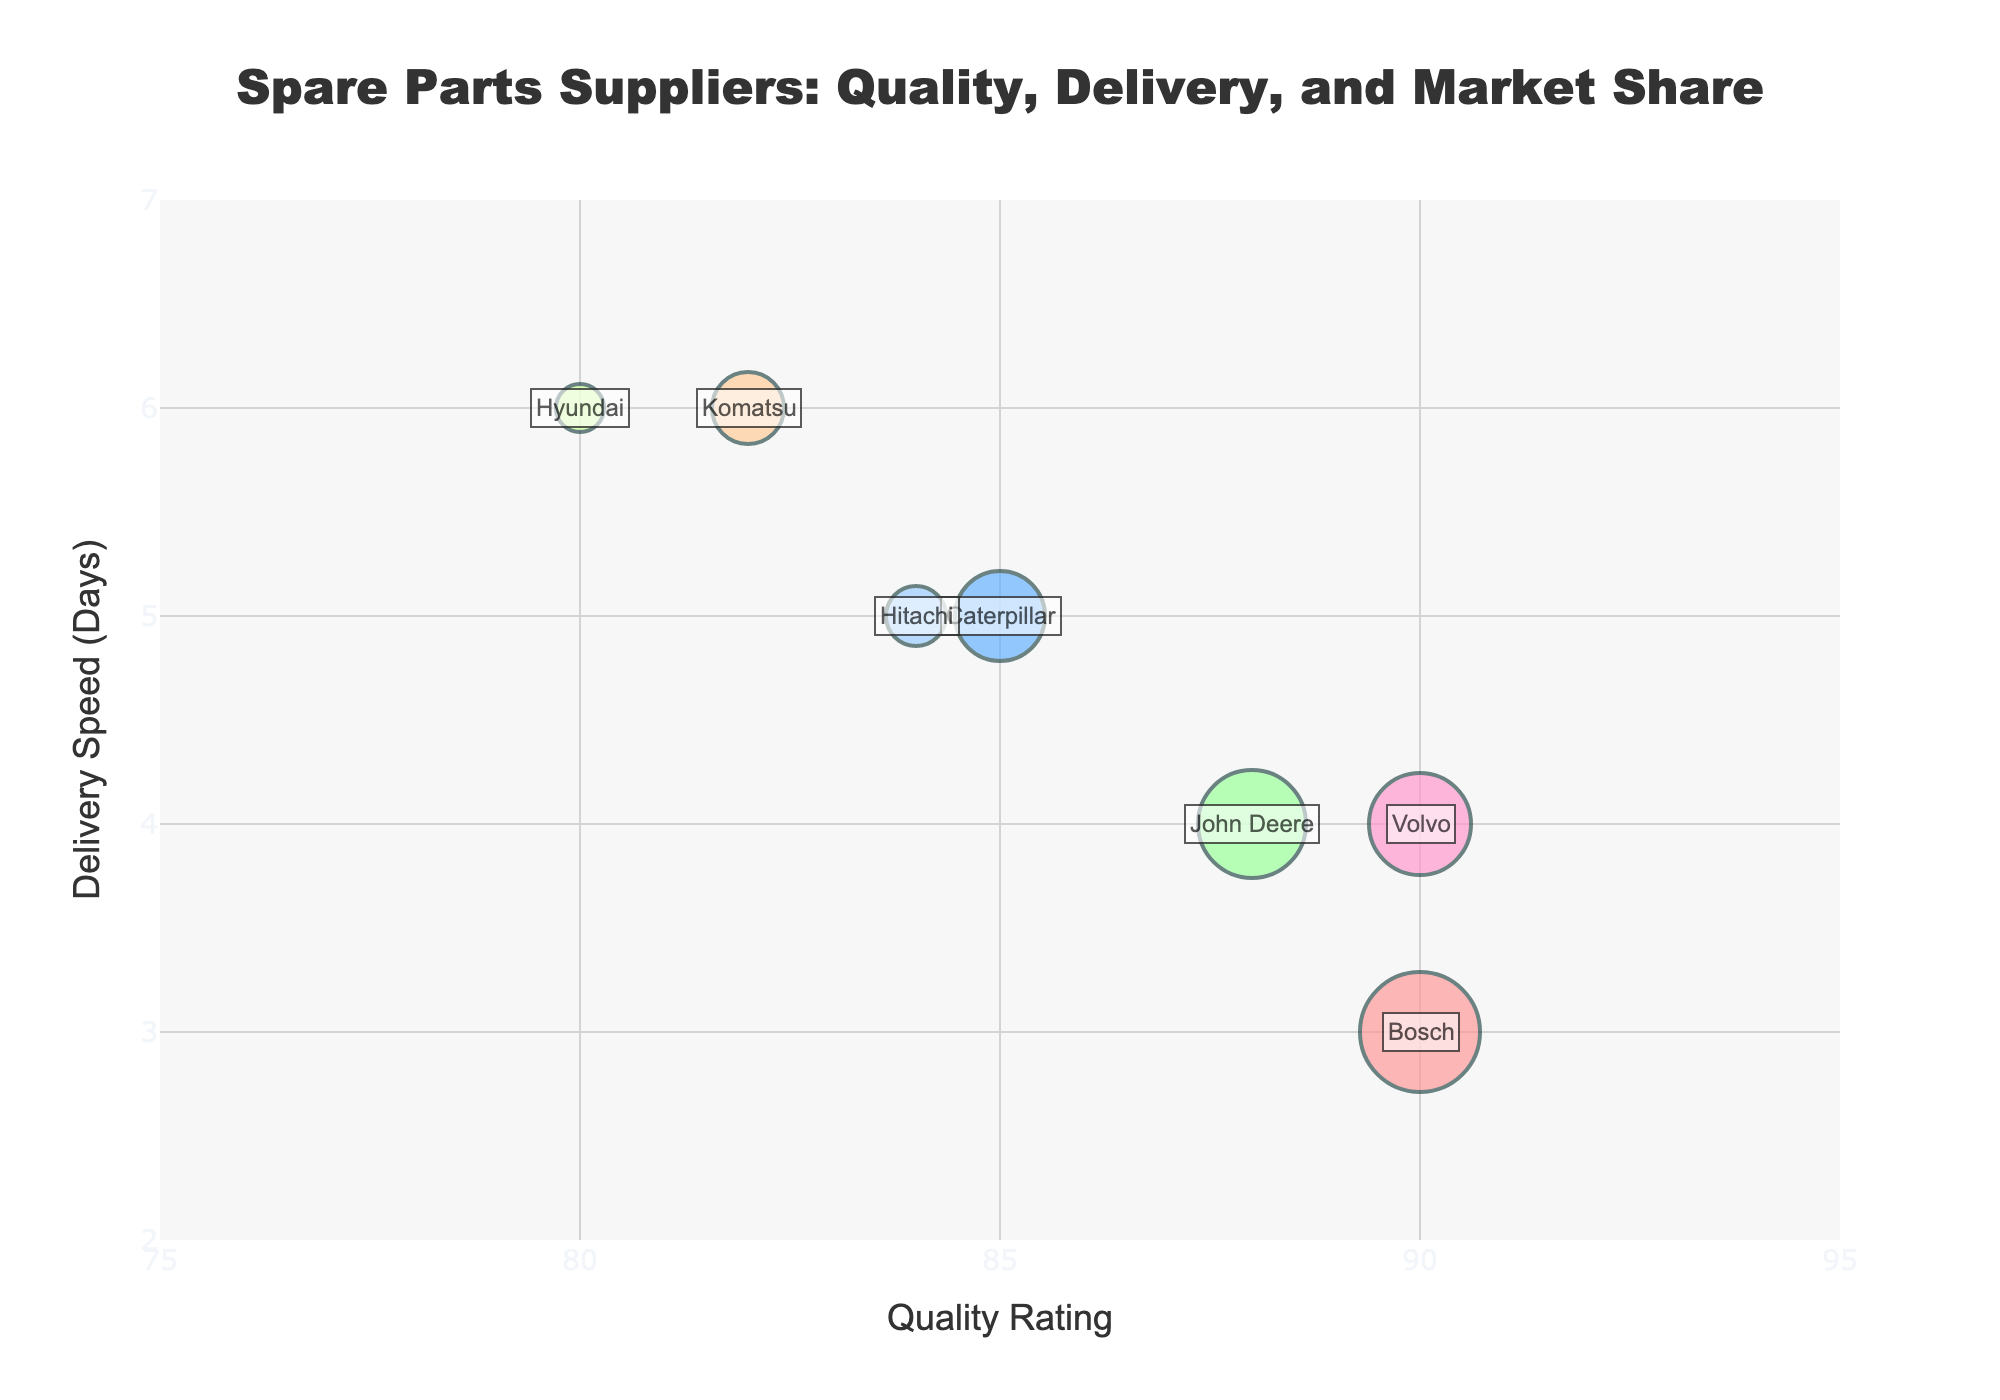How many suppliers have a Quality Rating of 90? Identify the suppliers with a Quality Rating of 90 by looking at the x-axis values and seeing which companies are positioned at 90 on that axis.
Answer: Two (Bosch and Volvo) Which supplier has the highest Delivery Speed? Look at the y-axis and find the supplier that is positioned highest on the axis representing Delivery Speed.
Answer: Hyundai (6 days) What is the average Market Share of all the suppliers? Sum the Market Share values for all suppliers (20 + 15 + 18 + 12 + 17 + 10 + 8 = 100) and then divide by the number of suppliers (7).
Answer: 14.29 Which supplier has the highest Quality Rating and what is their Market Share? Identify the highest value on the x-axis for Quality Rating and check the corresponding Market Share.
Answer: Bosch and Volvo (both have a Quality Rating of 90), Bosch's Market Share is 20%, and Volvo's Market Share is 17% Compare the Quality Rating and Delivery Speed between Caterpillar and John Deere. Locate both suppliers on the chart. Caterpillar's Quality Rating is 85 with a Delivery Speed of 5 days, and John Deere's Quality Rating is 88 with a Delivery Speed of 4 days.
Answer: Caterpillar: 85 Quality Rating, 5 days Delivery Speed; John Deere: 88 Quality Rating, 4 days Delivery Speed Which supplier has the smallest Market Share and how fast is their delivery? Identify the smallest bubble and check its corresponding y-axis value for Delivery Speed.
Answer: Hyundai (Market Share 8%, Delivery Speed 6 days) What is the range of Quality Ratings among the suppliers? Find the minimum and maximum Quality Ratings by looking at the x-axis values. The range is the difference between these values (90 - 80 = 10).
Answer: 10 How does Hitachi's Delivery Speed compare to the average Delivery Speed? Calculate the average Delivery Speed by summing all Delivery Speeds (3 + 5 + 4 + 6 + 4 + 5 + 6 = 33) and dividing by the number of suppliers (7). Then compare Hitachi's Delivery Speed to this average.
Answer: Average Delivery Speed: 4.71 days, Hitachi's Delivery Speed: 5 days, Hitachi's Delivery Speed is above average Which supplier has the largest bubble and what does it represent? Locate the largest bubble on the chart, which represents market share.
Answer: Bosch (largest bubble representing 20% Market Share) 